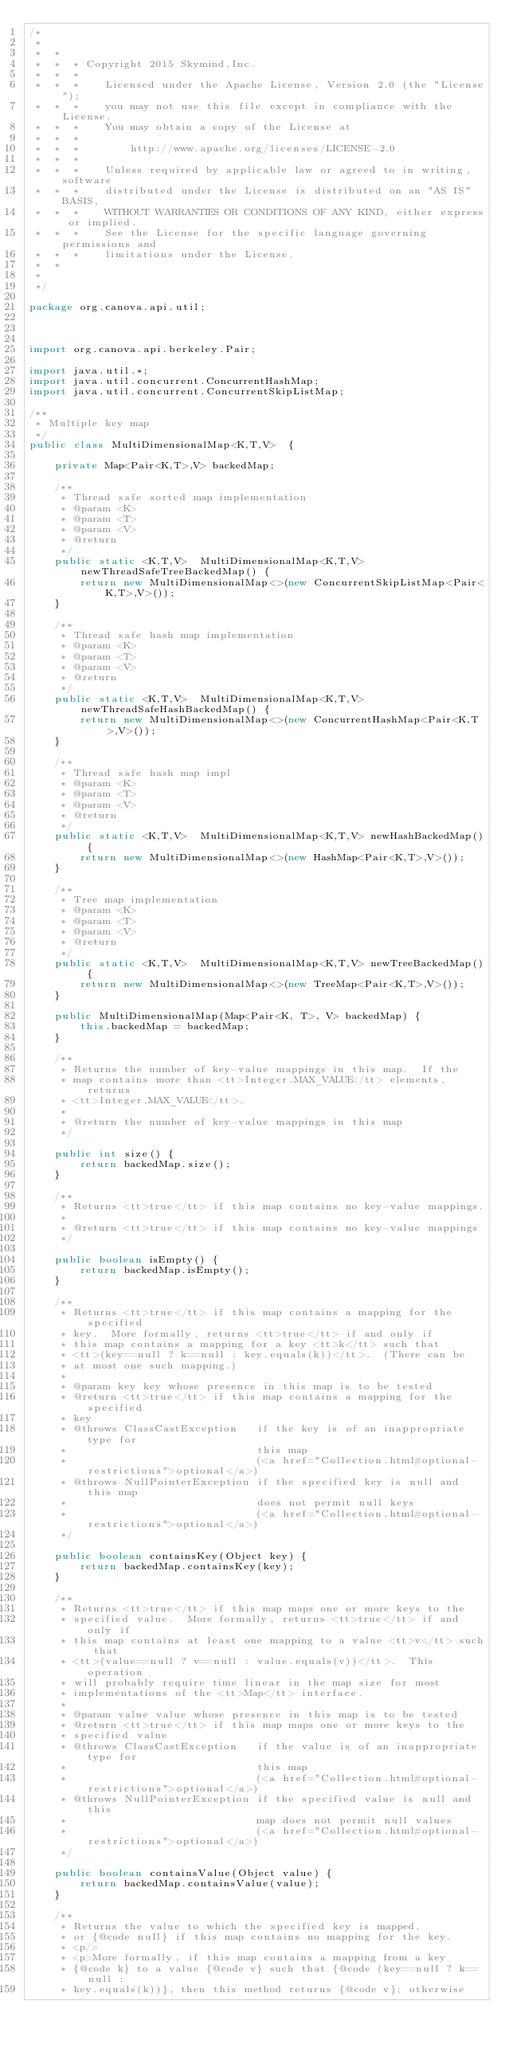Convert code to text. <code><loc_0><loc_0><loc_500><loc_500><_Java_>/*
 *
 *  *
 *  *  * Copyright 2015 Skymind,Inc.
 *  *  *
 *  *  *    Licensed under the Apache License, Version 2.0 (the "License");
 *  *  *    you may not use this file except in compliance with the License.
 *  *  *    You may obtain a copy of the License at
 *  *  *
 *  *  *        http://www.apache.org/licenses/LICENSE-2.0
 *  *  *
 *  *  *    Unless required by applicable law or agreed to in writing, software
 *  *  *    distributed under the License is distributed on an "AS IS" BASIS,
 *  *  *    WITHOUT WARRANTIES OR CONDITIONS OF ANY KIND, either express or implied.
 *  *  *    See the License for the specific language governing permissions and
 *  *  *    limitations under the License.
 *  *
 *
 */

package org.canova.api.util;



import org.canova.api.berkeley.Pair;

import java.util.*;
import java.util.concurrent.ConcurrentHashMap;
import java.util.concurrent.ConcurrentSkipListMap;

/**
 * Multiple key map
 */
public class MultiDimensionalMap<K,T,V>  {

    private Map<Pair<K,T>,V> backedMap;

    /**
     * Thread safe sorted map implementation
     * @param <K>
     * @param <T>
     * @param <V>
     * @return
     */
    public static <K,T,V>  MultiDimensionalMap<K,T,V> newThreadSafeTreeBackedMap() {
        return new MultiDimensionalMap<>(new ConcurrentSkipListMap<Pair<K,T>,V>());
    }

    /**
     * Thread safe hash map implementation
     * @param <K>
     * @param <T>
     * @param <V>
     * @return
     */
    public static <K,T,V>  MultiDimensionalMap<K,T,V> newThreadSafeHashBackedMap() {
        return new MultiDimensionalMap<>(new ConcurrentHashMap<Pair<K,T>,V>());
    }

    /**
     * Thread safe hash map impl
     * @param <K>
     * @param <T>
     * @param <V>
     * @return
     */
    public static <K,T,V>  MultiDimensionalMap<K,T,V> newHashBackedMap() {
        return new MultiDimensionalMap<>(new HashMap<Pair<K,T>,V>());
    }

    /**
     * Tree map implementation
     * @param <K>
     * @param <T>
     * @param <V>
     * @return
     */
    public static <K,T,V>  MultiDimensionalMap<K,T,V> newTreeBackedMap() {
        return new MultiDimensionalMap<>(new TreeMap<Pair<K,T>,V>());
    }

    public MultiDimensionalMap(Map<Pair<K, T>, V> backedMap) {
        this.backedMap = backedMap;
    }

    /**
     * Returns the number of key-value mappings in this map.  If the
     * map contains more than <tt>Integer.MAX_VALUE</tt> elements, returns
     * <tt>Integer.MAX_VALUE</tt>.
     *
     * @return the number of key-value mappings in this map
     */
    
    public int size() {
        return backedMap.size();
    }

    /**
     * Returns <tt>true</tt> if this map contains no key-value mappings.
     *
     * @return <tt>true</tt> if this map contains no key-value mappings
     */
    
    public boolean isEmpty() {
        return backedMap.isEmpty();
    }

    /**
     * Returns <tt>true</tt> if this map contains a mapping for the specified
     * key.  More formally, returns <tt>true</tt> if and only if
     * this map contains a mapping for a key <tt>k</tt> such that
     * <tt>(key==null ? k==null : key.equals(k))</tt>.  (There can be
     * at most one such mapping.)
     *
     * @param key key whose presence in this map is to be tested
     * @return <tt>true</tt> if this map contains a mapping for the specified
     * key
     * @throws ClassCastException   if the key is of an inappropriate type for
     *                              this map
     *                              (<a href="Collection.html#optional-restrictions">optional</a>)
     * @throws NullPointerException if the specified key is null and this map
     *                              does not permit null keys
     *                              (<a href="Collection.html#optional-restrictions">optional</a>)
     */
    
    public boolean containsKey(Object key) {
        return backedMap.containsKey(key);
    }

    /**
     * Returns <tt>true</tt> if this map maps one or more keys to the
     * specified value.  More formally, returns <tt>true</tt> if and only if
     * this map contains at least one mapping to a value <tt>v</tt> such that
     * <tt>(value==null ? v==null : value.equals(v))</tt>.  This operation
     * will probably require time linear in the map size for most
     * implementations of the <tt>Map</tt> interface.
     *
     * @param value value whose presence in this map is to be tested
     * @return <tt>true</tt> if this map maps one or more keys to the
     * specified value
     * @throws ClassCastException   if the value is of an inappropriate type for
     *                              this map
     *                              (<a href="Collection.html#optional-restrictions">optional</a>)
     * @throws NullPointerException if the specified value is null and this
     *                              map does not permit null values
     *                              (<a href="Collection.html#optional-restrictions">optional</a>)
     */
    
    public boolean containsValue(Object value) {
        return backedMap.containsValue(value);
    }

    /**
     * Returns the value to which the specified key is mapped,
     * or {@code null} if this map contains no mapping for the key.
     * <p/>
     * <p>More formally, if this map contains a mapping from a key
     * {@code k} to a value {@code v} such that {@code (key==null ? k==null :
     * key.equals(k))}, then this method returns {@code v}; otherwise</code> 